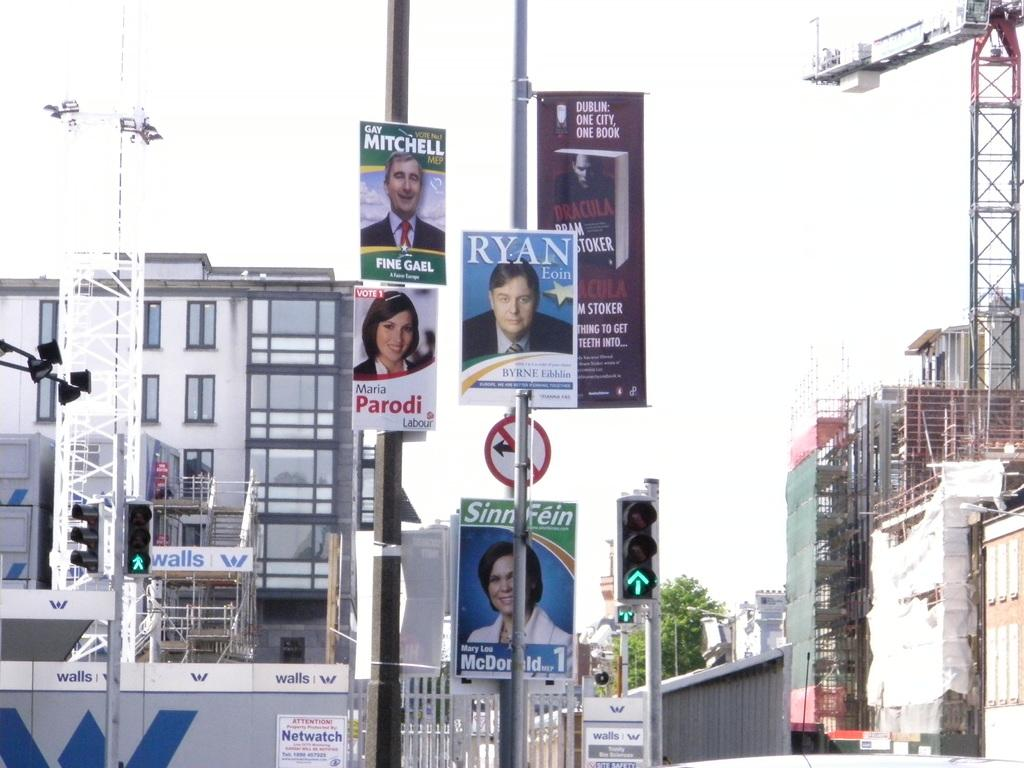<image>
Present a compact description of the photo's key features. Poles littered with campaign ads for the candidates Parodi, Ryan and Mitchell. 